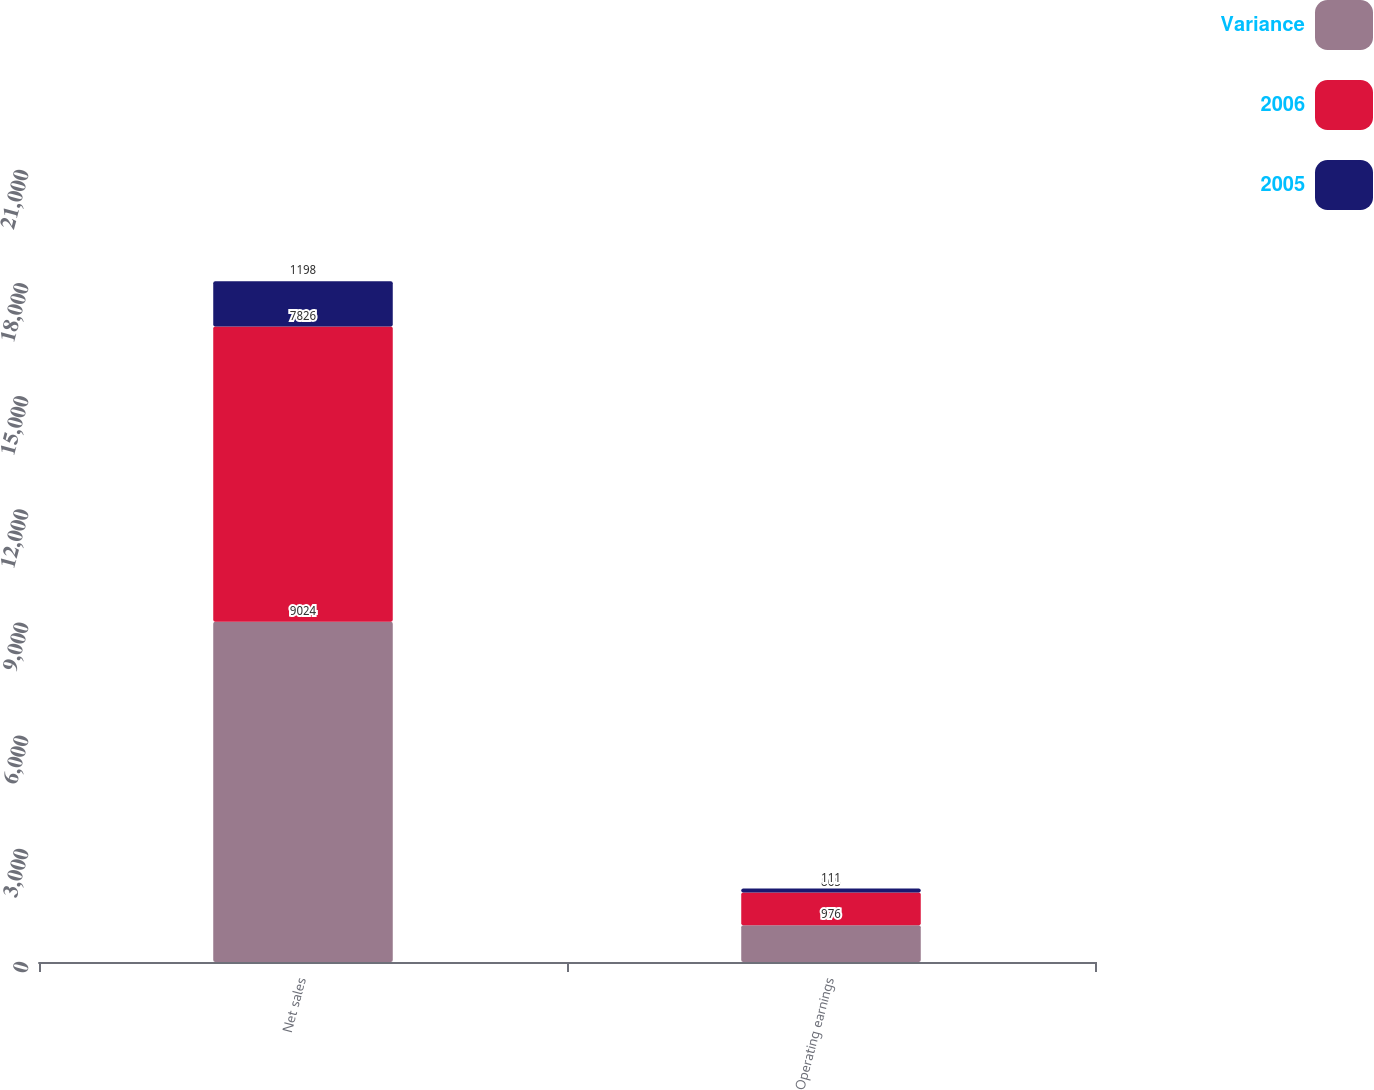Convert chart. <chart><loc_0><loc_0><loc_500><loc_500><stacked_bar_chart><ecel><fcel>Net sales<fcel>Operating earnings<nl><fcel>Variance<fcel>9024<fcel>976<nl><fcel>2006<fcel>7826<fcel>865<nl><fcel>2005<fcel>1198<fcel>111<nl></chart> 